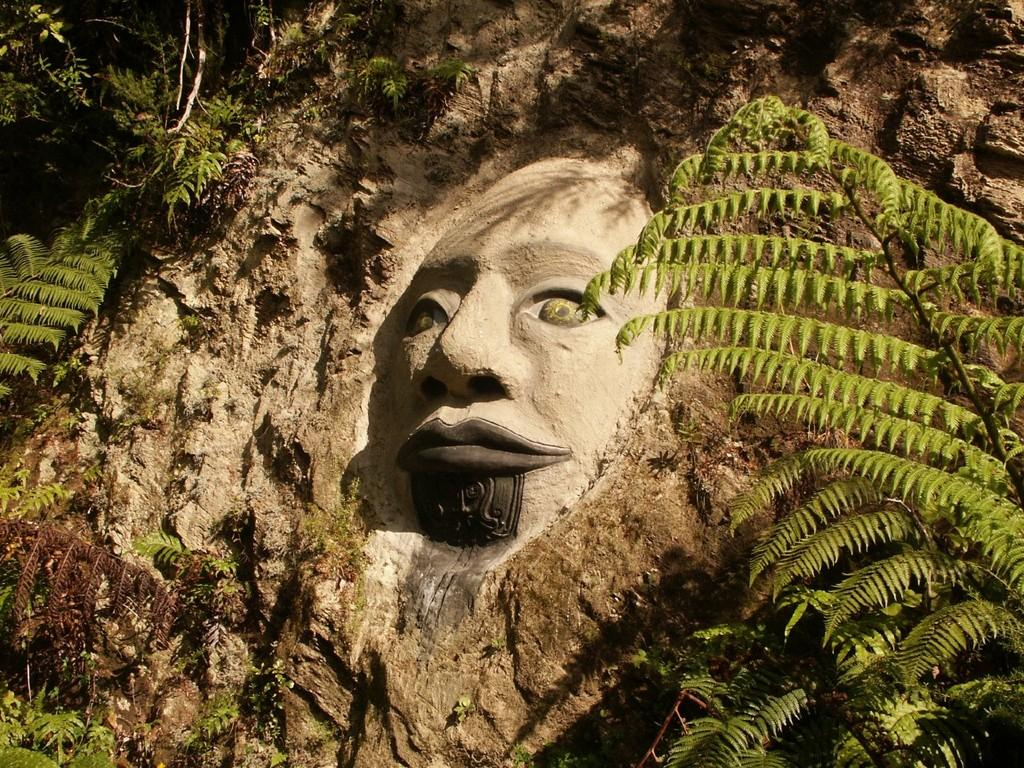What is the main subject of the image? There is a sculpture in the image. Where is the sculpture located? The sculpture is on a mountain. What type of vegetation can be seen in the image? There are plants and trees in the image. What type of song is being sung by the sculpture in the image? There is no indication in the image that the sculpture is singing a song, as sculptures are typically inanimate objects. 